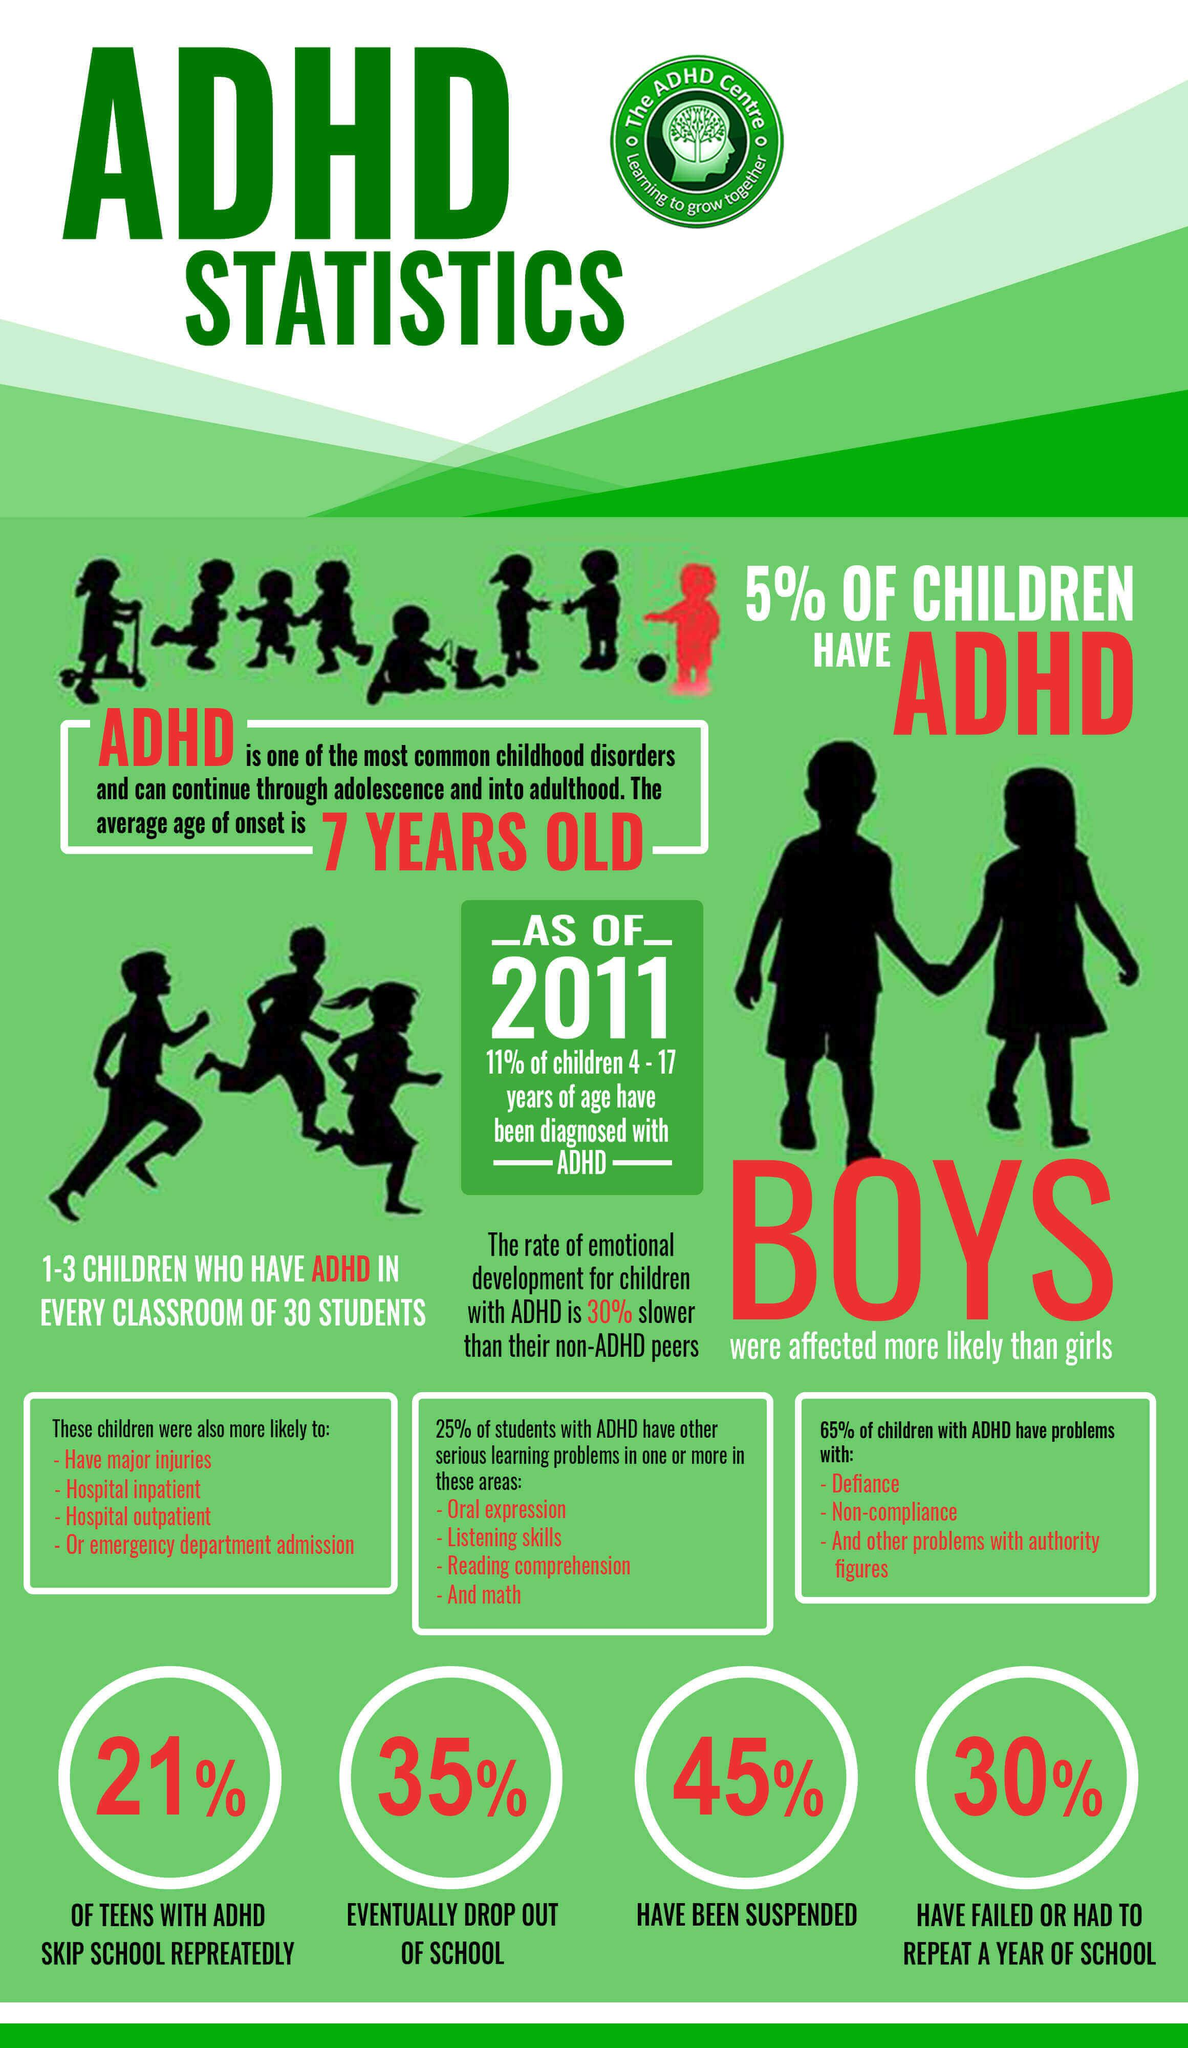Mention a couple of crucial points in this snapshot. There are two silhouettes of children depicted above the bold red text that reads 'BOYS' in the image. It is expected that in a classroom of 30 students, only 1-3 children will have ADHD. The emotional development of children with ADHD is diagnosed differently from that of normal children, with a rate of development that is 30% slower than their peers without ADHD. The total count of the text "ADHD" in the infographic is 10. There exist three white rectangles located directly above the four circles. 